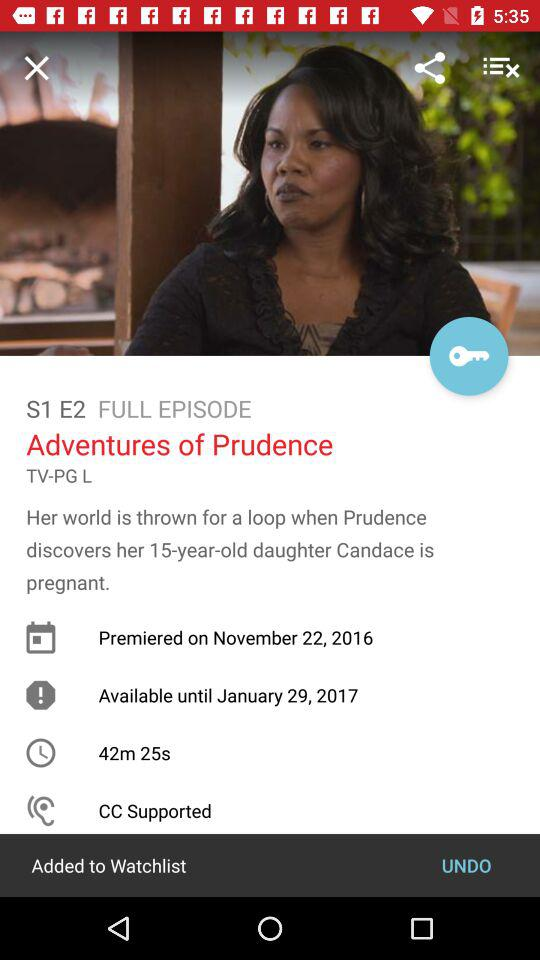What is the name of the episode? The name of the episode is "Adventures of Prudence". 